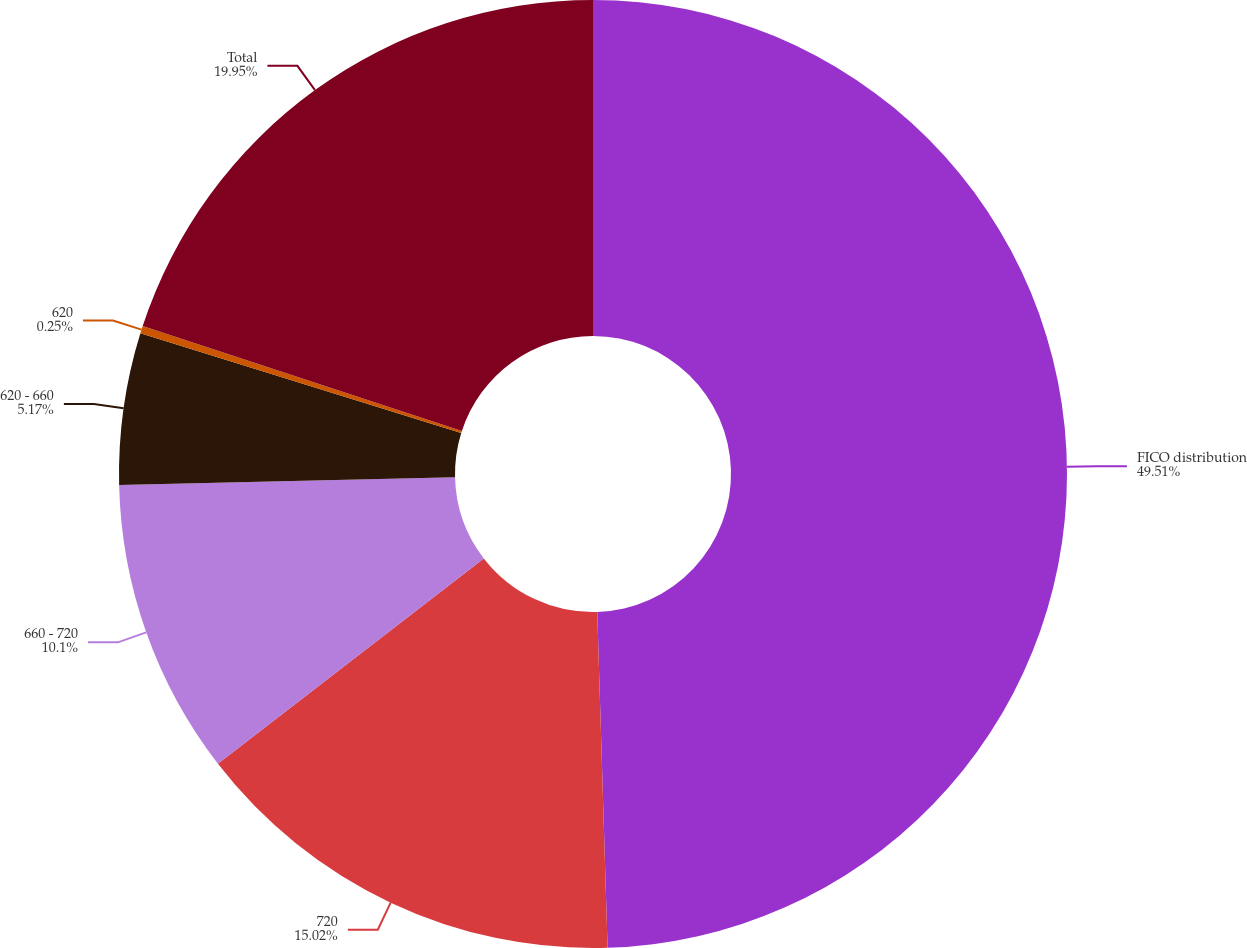Convert chart to OTSL. <chart><loc_0><loc_0><loc_500><loc_500><pie_chart><fcel>FICO distribution<fcel>720<fcel>660 - 720<fcel>620 - 660<fcel>620<fcel>Total<nl><fcel>49.51%<fcel>15.02%<fcel>10.1%<fcel>5.17%<fcel>0.25%<fcel>19.95%<nl></chart> 